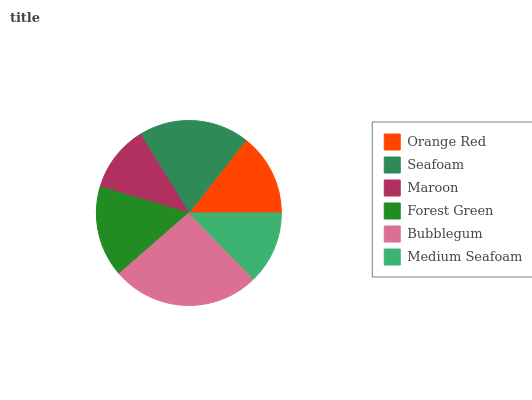Is Maroon the minimum?
Answer yes or no. Yes. Is Bubblegum the maximum?
Answer yes or no. Yes. Is Seafoam the minimum?
Answer yes or no. No. Is Seafoam the maximum?
Answer yes or no. No. Is Seafoam greater than Orange Red?
Answer yes or no. Yes. Is Orange Red less than Seafoam?
Answer yes or no. Yes. Is Orange Red greater than Seafoam?
Answer yes or no. No. Is Seafoam less than Orange Red?
Answer yes or no. No. Is Forest Green the high median?
Answer yes or no. Yes. Is Orange Red the low median?
Answer yes or no. Yes. Is Orange Red the high median?
Answer yes or no. No. Is Seafoam the low median?
Answer yes or no. No. 